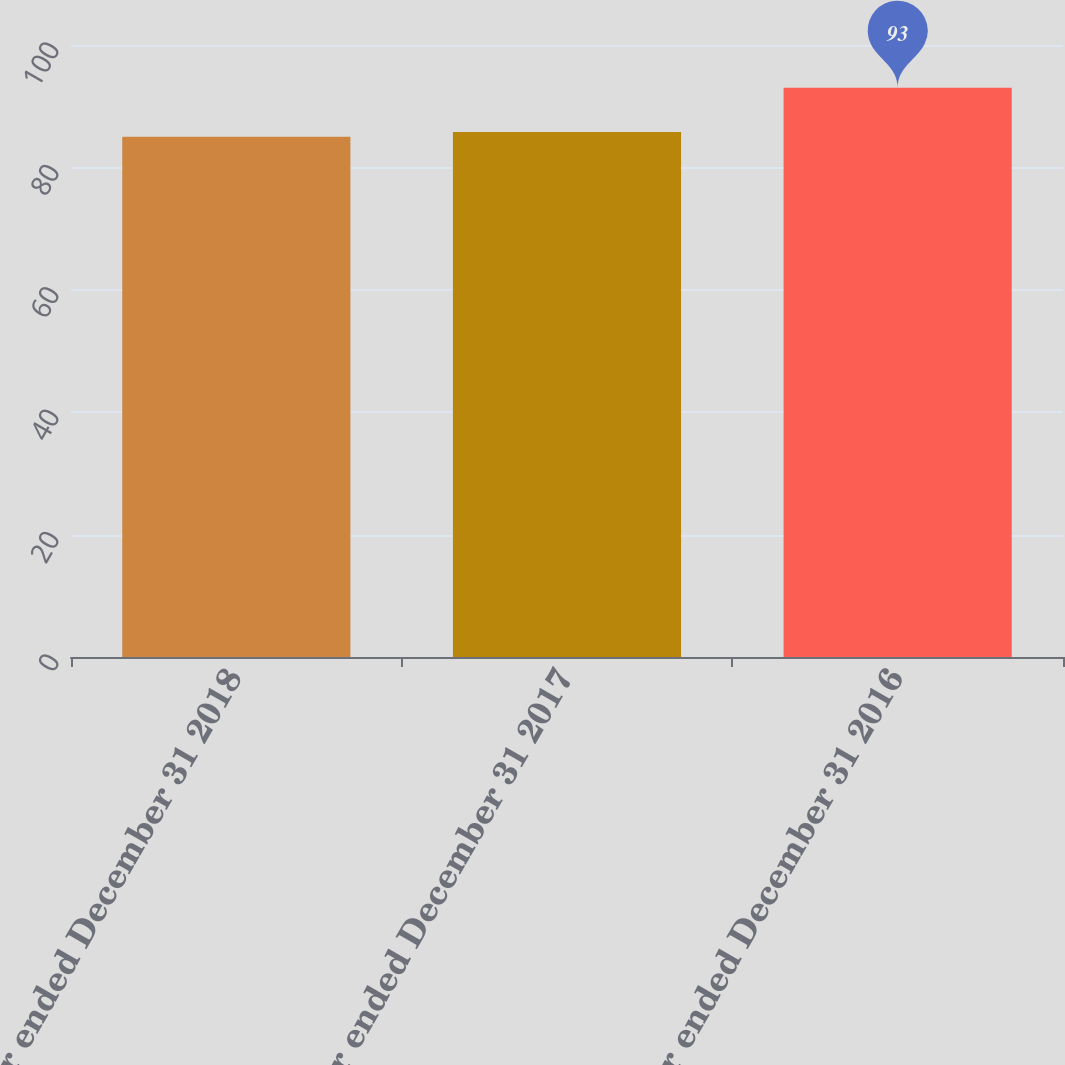Convert chart to OTSL. <chart><loc_0><loc_0><loc_500><loc_500><bar_chart><fcel>Year ended December 31 2018<fcel>Year ended December 31 2017<fcel>Year ended December 31 2016<nl><fcel>85<fcel>85.8<fcel>93<nl></chart> 